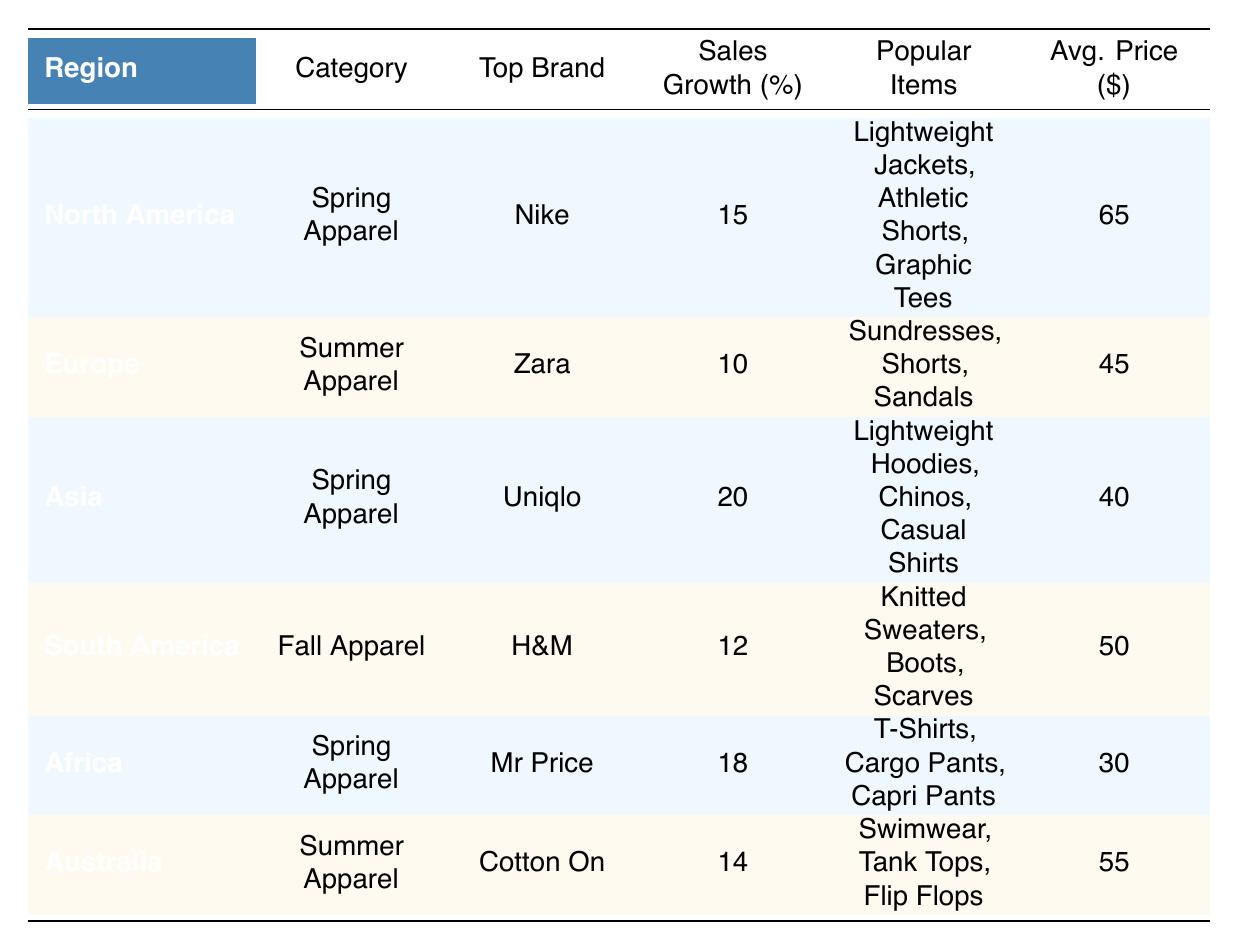What is the top brand for Spring Apparel in North America? The table indicates that for North America, the category is Spring Apparel and the top brand listed is Nike.
Answer: Nike Which region had the highest sales growth percentage for Spring Apparel? When comparing the sales growth percentages for Spring Apparel across regions, North America shows 15%, Asia 20%, and Africa 18%. Asia has the highest percentage at 20%.
Answer: Asia What are the popular items for Summer Apparel in Europe? Looking at the entry for Europe under the Summer Apparel category, the popular items listed are Sundresses, Shorts, and Sandals.
Answer: Sundresses, Shorts, Sandals Is H&M the top brand in South America? The table shows that the top brand for Fall Apparel in South America is H&M, making this statement true.
Answer: Yes Calculate the average sale price of Spring Apparel across all regions. The average sale price for Spring Apparel can be calculated using the prices from the corresponding entries: North America ($65), Asia ($40), and Africa ($30). The sum is $135, and there are 3 regions, so the average is $135/3 = $45.
Answer: 45 What popular items are associated with the top brand in Asia? According to the table, Uniqlo is the top brand for Spring Apparel in Asia, and the popular items listed for this brand are Lightweight Hoodies, Chinos, and Casual Shirts.
Answer: Lightweight Hoodies, Chinos, Casual Shirts Does Australia have a higher average price for Summer Apparel compared to Europe? The average price for Summer Apparel in Australia is $55, while in Europe, it is $45. Since $55 is greater than $45, the answer is yes.
Answer: Yes Which region has the lowest average price for apparel? Looking at the average prices for each region: North America ($65), Europe ($45), Asia ($40), South America ($50), Africa ($30), and Australia ($55). Africa has the lowest price at $30.
Answer: Africa What are the popular items for Fall Apparel in South America? The table shows that the popular items for Fall Apparel in South America are Knitted Sweaters, Boots, and Scarves.
Answer: Knitted Sweaters, Boots, Scarves 